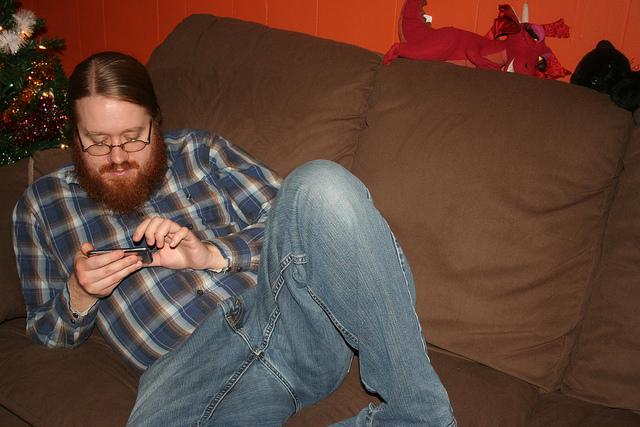What animal is the red stuffed animal? Please explain your reasoning. dragon. The stuffed animal is a mystical lizard creature that breathes fire. 